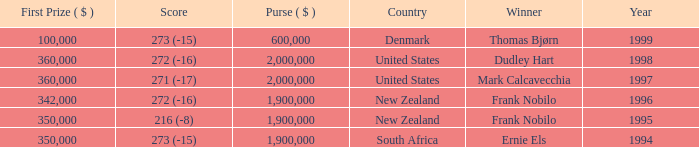Parse the full table. {'header': ['First Prize ( $ )', 'Score', 'Purse ( $ )', 'Country', 'Winner', 'Year'], 'rows': [['100,000', '273 (-15)', '600,000', 'Denmark', 'Thomas Bjørn', '1999'], ['360,000', '272 (-16)', '2,000,000', 'United States', 'Dudley Hart', '1998'], ['360,000', '271 (-17)', '2,000,000', 'United States', 'Mark Calcavecchia', '1997'], ['342,000', '272 (-16)', '1,900,000', 'New Zealand', 'Frank Nobilo', '1996'], ['350,000', '216 (-8)', '1,900,000', 'New Zealand', 'Frank Nobilo', '1995'], ['350,000', '273 (-15)', '1,900,000', 'South Africa', 'Ernie Els', '1994']]} What was the top first place prize in 1997? 360000.0. 